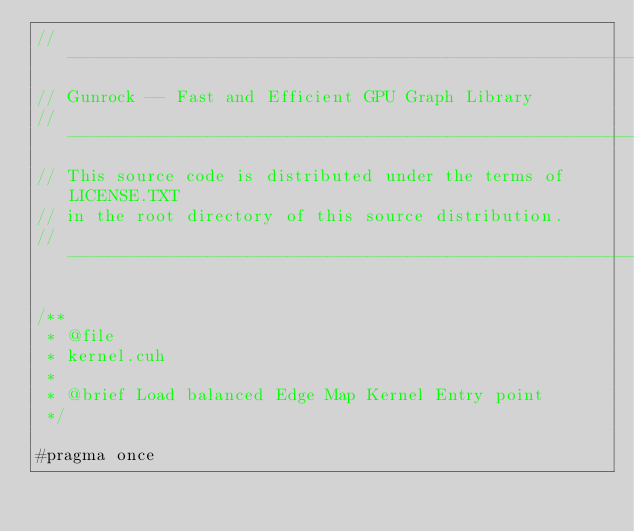<code> <loc_0><loc_0><loc_500><loc_500><_Cuda_>// ----------------------------------------------------------------
// Gunrock -- Fast and Efficient GPU Graph Library
// ----------------------------------------------------------------
// This source code is distributed under the terms of LICENSE.TXT
// in the root directory of this source distribution.
// ----------------------------------------------------------------

/**
 * @file
 * kernel.cuh
 *
 * @brief Load balanced Edge Map Kernel Entry point
 */

#pragma once</code> 